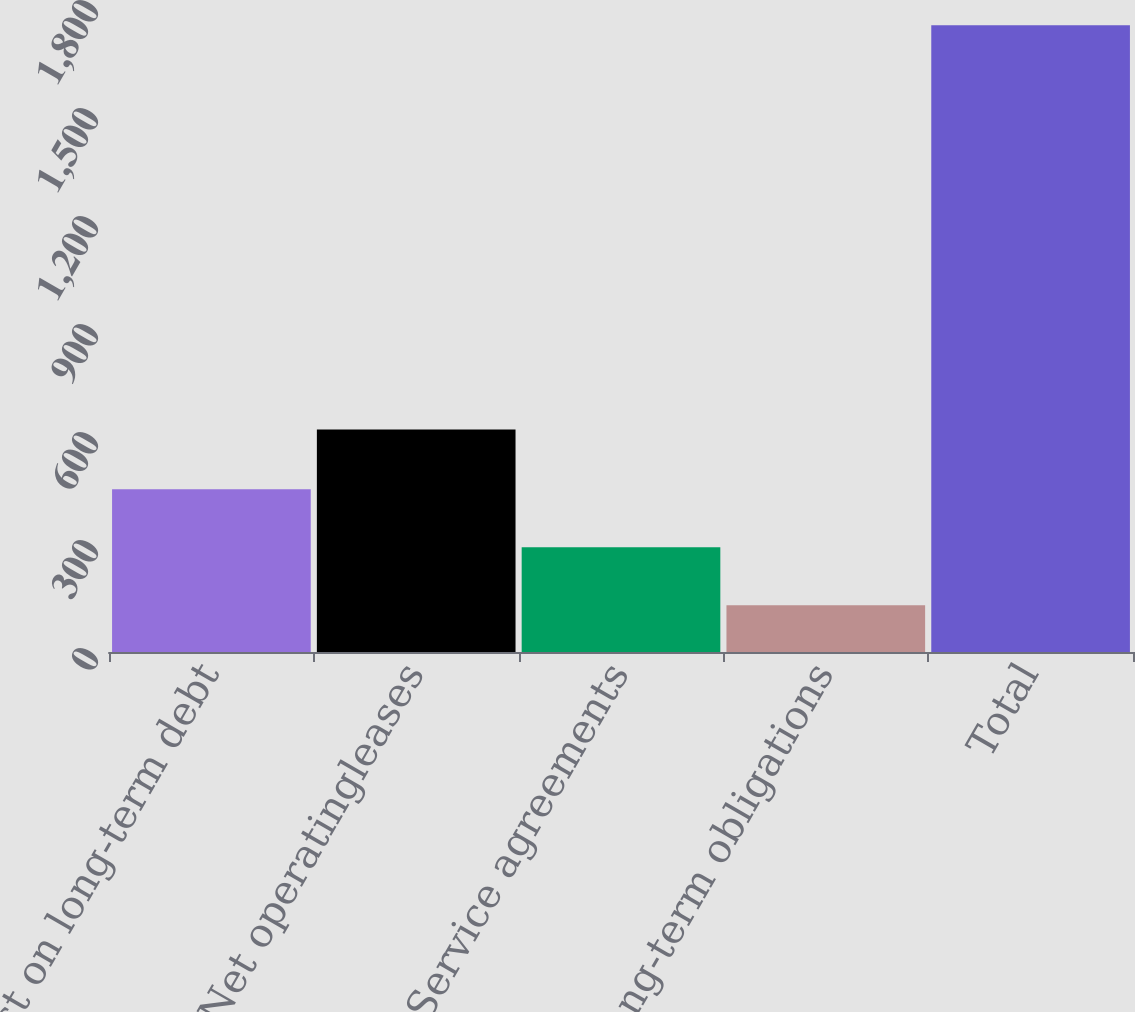<chart> <loc_0><loc_0><loc_500><loc_500><bar_chart><fcel>Interest on long-term debt<fcel>Net operatingleases<fcel>Service agreements<fcel>Other long-term obligations<fcel>Total<nl><fcel>452.2<fcel>618<fcel>291.1<fcel>130<fcel>1741<nl></chart> 